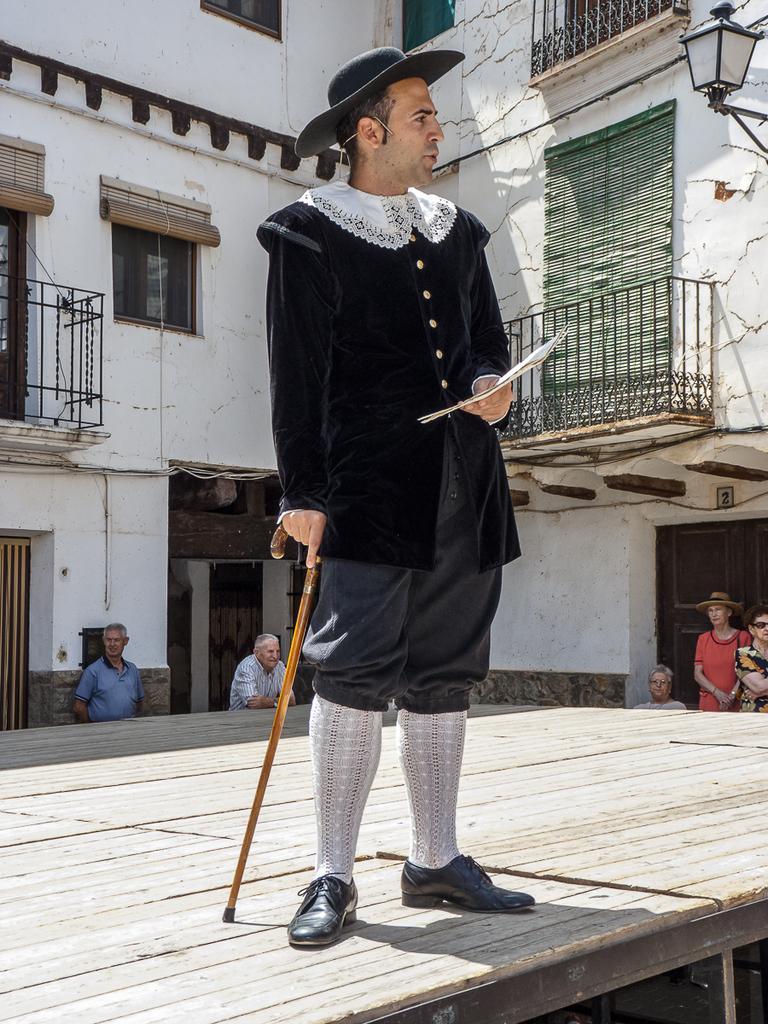Could you give a brief overview of what you see in this image? In the image we can see a man standing, wearing clothes, hat, shoes and holding stick in one hand and on the other hand, we can see paper, and the man is standing on the wooden surface. We can see there are even other people, wearing clothes. Here we can see building, fence, lantern and the windows of the building. 